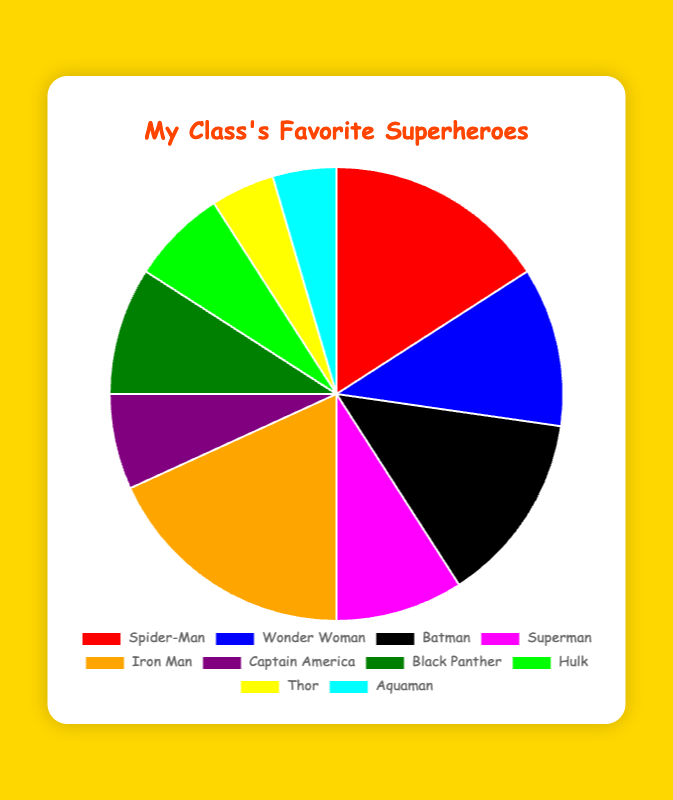Which superhero has the highest number of votes? Iron Man has 8 votes, which is the highest among all the superheroes in the chart.
Answer: Iron Man Which superhero has the lowest number of votes? Both Thor and Aquaman have the lowest number of votes, with 2 votes each.
Answer: Thor and Aquaman How many more votes does Spider-Man have compared to Batman? Spider-Man has 7 votes and Batman has 6 votes. The difference is 7 - 6 = 1 vote.
Answer: 1 What is the total number of votes for all the superheroes combined? Summing all the votes: 7 (Spider-Man) + 5 (Wonder Woman) + 6 (Batman) + 4 (Superman) + 8 (Iron Man) + 3 (Captain America) + 4 (Black Panther) + 3 (Hulk) + 2 (Thor) + 2 (Aquaman) = 44 votes.
Answer: 44 Which superheroes have exactly 4 votes each? Both Superman and Black Panther have exactly 4 votes each as shown in the chart.
Answer: Superman and Black Panther How many more votes does Iron Man have compared to Captain America and Thor combined? Iron Man has 8 votes. Captain America and Thor combined have 3 + 2 = 5 votes. The difference is 8 - 5 = 3 votes.
Answer: 3 Which superhero has a yellow section on the chart? The yellow section of the chart corresponds to Thor.
Answer: Thor How many superheroes have more than 5 votes? Spider-Man (7 votes), Batman (6 votes), and Iron Man (8 votes) all have more than 5 votes.
Answer: 3 What is the sum of votes for Wonder Woman, Hulk, and Aquaman? Summing the votes: 5 (Wonder Woman) + 3 (Hulk) + 2 (Aquaman) = 10 votes.
Answer: 10 If you add up the votes for Spider-Man and Iron Man, what percentage of the total votes does this represent? Spider-Man and Iron Man together have 7 + 8 = 15 votes. The total votes are 44. The percentage is (15 / 44) * 100 ≈ 34.09%.
Answer: 34.09% 